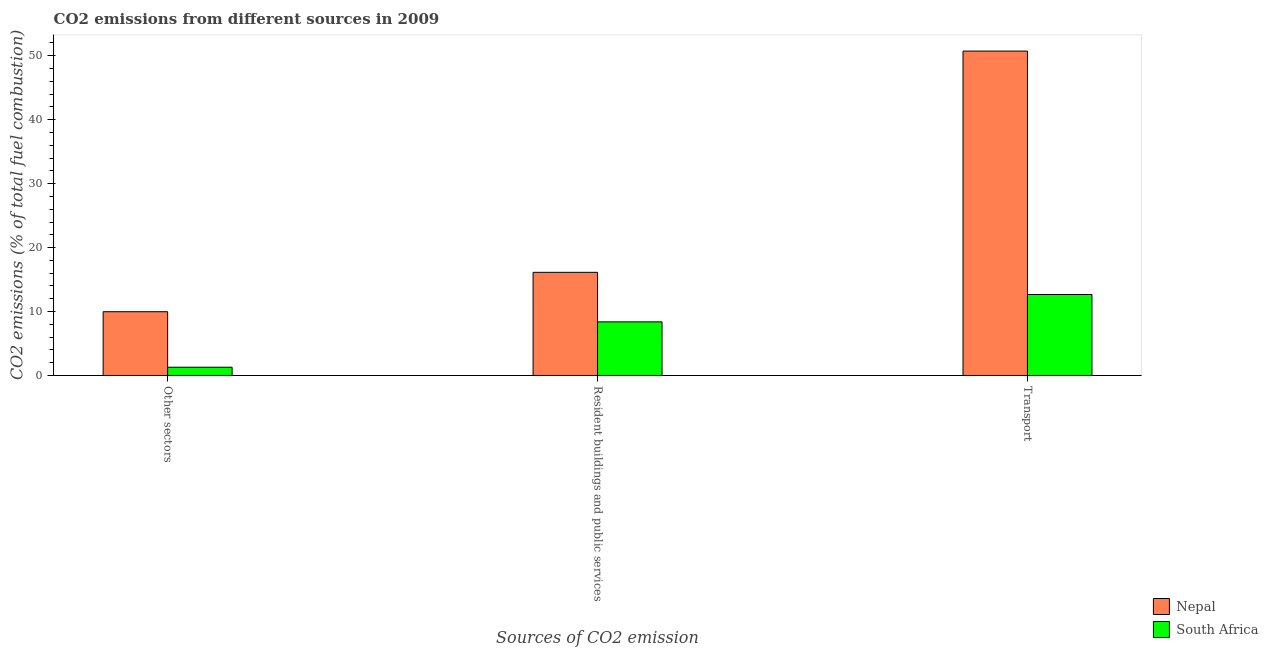How many different coloured bars are there?
Keep it short and to the point. 2. How many bars are there on the 1st tick from the left?
Your answer should be very brief. 2. How many bars are there on the 1st tick from the right?
Make the answer very short. 2. What is the label of the 1st group of bars from the left?
Your answer should be compact. Other sectors. What is the percentage of co2 emissions from other sectors in South Africa?
Give a very brief answer. 1.29. Across all countries, what is the maximum percentage of co2 emissions from resident buildings and public services?
Keep it short and to the point. 16.13. Across all countries, what is the minimum percentage of co2 emissions from transport?
Provide a succinct answer. 12.66. In which country was the percentage of co2 emissions from other sectors maximum?
Your answer should be very brief. Nepal. In which country was the percentage of co2 emissions from other sectors minimum?
Your answer should be very brief. South Africa. What is the total percentage of co2 emissions from transport in the graph?
Offer a very short reply. 63.4. What is the difference between the percentage of co2 emissions from transport in South Africa and that in Nepal?
Offer a very short reply. -38.07. What is the difference between the percentage of co2 emissions from transport in Nepal and the percentage of co2 emissions from other sectors in South Africa?
Your answer should be very brief. 49.44. What is the average percentage of co2 emissions from resident buildings and public services per country?
Give a very brief answer. 12.26. What is the difference between the percentage of co2 emissions from resident buildings and public services and percentage of co2 emissions from other sectors in South Africa?
Your answer should be very brief. 7.09. What is the ratio of the percentage of co2 emissions from transport in South Africa to that in Nepal?
Make the answer very short. 0.25. Is the difference between the percentage of co2 emissions from other sectors in Nepal and South Africa greater than the difference between the percentage of co2 emissions from resident buildings and public services in Nepal and South Africa?
Provide a short and direct response. Yes. What is the difference between the highest and the second highest percentage of co2 emissions from resident buildings and public services?
Provide a short and direct response. 7.75. What is the difference between the highest and the lowest percentage of co2 emissions from other sectors?
Provide a short and direct response. 8.68. Is the sum of the percentage of co2 emissions from resident buildings and public services in South Africa and Nepal greater than the maximum percentage of co2 emissions from other sectors across all countries?
Your response must be concise. Yes. What does the 1st bar from the left in Transport represents?
Your response must be concise. Nepal. What does the 1st bar from the right in Transport represents?
Your answer should be very brief. South Africa. How many countries are there in the graph?
Make the answer very short. 2. Where does the legend appear in the graph?
Make the answer very short. Bottom right. How are the legend labels stacked?
Ensure brevity in your answer.  Vertical. What is the title of the graph?
Give a very brief answer. CO2 emissions from different sources in 2009. Does "Luxembourg" appear as one of the legend labels in the graph?
Keep it short and to the point. No. What is the label or title of the X-axis?
Give a very brief answer. Sources of CO2 emission. What is the label or title of the Y-axis?
Your answer should be compact. CO2 emissions (% of total fuel combustion). What is the CO2 emissions (% of total fuel combustion) in Nepal in Other sectors?
Your response must be concise. 9.97. What is the CO2 emissions (% of total fuel combustion) of South Africa in Other sectors?
Provide a short and direct response. 1.29. What is the CO2 emissions (% of total fuel combustion) of Nepal in Resident buildings and public services?
Your answer should be compact. 16.13. What is the CO2 emissions (% of total fuel combustion) of South Africa in Resident buildings and public services?
Provide a short and direct response. 8.38. What is the CO2 emissions (% of total fuel combustion) of Nepal in Transport?
Keep it short and to the point. 50.73. What is the CO2 emissions (% of total fuel combustion) of South Africa in Transport?
Provide a short and direct response. 12.66. Across all Sources of CO2 emission, what is the maximum CO2 emissions (% of total fuel combustion) of Nepal?
Give a very brief answer. 50.73. Across all Sources of CO2 emission, what is the maximum CO2 emissions (% of total fuel combustion) of South Africa?
Your answer should be compact. 12.66. Across all Sources of CO2 emission, what is the minimum CO2 emissions (% of total fuel combustion) in Nepal?
Ensure brevity in your answer.  9.97. Across all Sources of CO2 emission, what is the minimum CO2 emissions (% of total fuel combustion) in South Africa?
Keep it short and to the point. 1.29. What is the total CO2 emissions (% of total fuel combustion) in Nepal in the graph?
Make the answer very short. 76.83. What is the total CO2 emissions (% of total fuel combustion) in South Africa in the graph?
Provide a succinct answer. 22.34. What is the difference between the CO2 emissions (% of total fuel combustion) in Nepal in Other sectors and that in Resident buildings and public services?
Your response must be concise. -6.16. What is the difference between the CO2 emissions (% of total fuel combustion) of South Africa in Other sectors and that in Resident buildings and public services?
Give a very brief answer. -7.09. What is the difference between the CO2 emissions (% of total fuel combustion) of Nepal in Other sectors and that in Transport?
Keep it short and to the point. -40.76. What is the difference between the CO2 emissions (% of total fuel combustion) in South Africa in Other sectors and that in Transport?
Your response must be concise. -11.38. What is the difference between the CO2 emissions (% of total fuel combustion) in Nepal in Resident buildings and public services and that in Transport?
Ensure brevity in your answer.  -34.6. What is the difference between the CO2 emissions (% of total fuel combustion) of South Africa in Resident buildings and public services and that in Transport?
Provide a succinct answer. -4.28. What is the difference between the CO2 emissions (% of total fuel combustion) of Nepal in Other sectors and the CO2 emissions (% of total fuel combustion) of South Africa in Resident buildings and public services?
Give a very brief answer. 1.59. What is the difference between the CO2 emissions (% of total fuel combustion) of Nepal in Other sectors and the CO2 emissions (% of total fuel combustion) of South Africa in Transport?
Give a very brief answer. -2.69. What is the difference between the CO2 emissions (% of total fuel combustion) of Nepal in Resident buildings and public services and the CO2 emissions (% of total fuel combustion) of South Africa in Transport?
Your response must be concise. 3.46. What is the average CO2 emissions (% of total fuel combustion) in Nepal per Sources of CO2 emission?
Your answer should be compact. 25.61. What is the average CO2 emissions (% of total fuel combustion) in South Africa per Sources of CO2 emission?
Your answer should be compact. 7.45. What is the difference between the CO2 emissions (% of total fuel combustion) of Nepal and CO2 emissions (% of total fuel combustion) of South Africa in Other sectors?
Give a very brief answer. 8.68. What is the difference between the CO2 emissions (% of total fuel combustion) in Nepal and CO2 emissions (% of total fuel combustion) in South Africa in Resident buildings and public services?
Keep it short and to the point. 7.75. What is the difference between the CO2 emissions (% of total fuel combustion) in Nepal and CO2 emissions (% of total fuel combustion) in South Africa in Transport?
Your answer should be very brief. 38.07. What is the ratio of the CO2 emissions (% of total fuel combustion) in Nepal in Other sectors to that in Resident buildings and public services?
Your answer should be compact. 0.62. What is the ratio of the CO2 emissions (% of total fuel combustion) in South Africa in Other sectors to that in Resident buildings and public services?
Your answer should be very brief. 0.15. What is the ratio of the CO2 emissions (% of total fuel combustion) of Nepal in Other sectors to that in Transport?
Offer a terse response. 0.2. What is the ratio of the CO2 emissions (% of total fuel combustion) of South Africa in Other sectors to that in Transport?
Your response must be concise. 0.1. What is the ratio of the CO2 emissions (% of total fuel combustion) of Nepal in Resident buildings and public services to that in Transport?
Provide a short and direct response. 0.32. What is the ratio of the CO2 emissions (% of total fuel combustion) of South Africa in Resident buildings and public services to that in Transport?
Offer a very short reply. 0.66. What is the difference between the highest and the second highest CO2 emissions (% of total fuel combustion) in Nepal?
Make the answer very short. 34.6. What is the difference between the highest and the second highest CO2 emissions (% of total fuel combustion) of South Africa?
Make the answer very short. 4.28. What is the difference between the highest and the lowest CO2 emissions (% of total fuel combustion) of Nepal?
Offer a very short reply. 40.76. What is the difference between the highest and the lowest CO2 emissions (% of total fuel combustion) in South Africa?
Give a very brief answer. 11.38. 